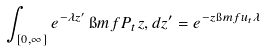<formula> <loc_0><loc_0><loc_500><loc_500>\int _ { [ 0 , \infty ] } e ^ { - \lambda z ^ { \prime } } \, \i m f { P _ { t } } { z , d z ^ { \prime } } = e ^ { - z \i m f { u _ { t } } { \lambda } }</formula> 